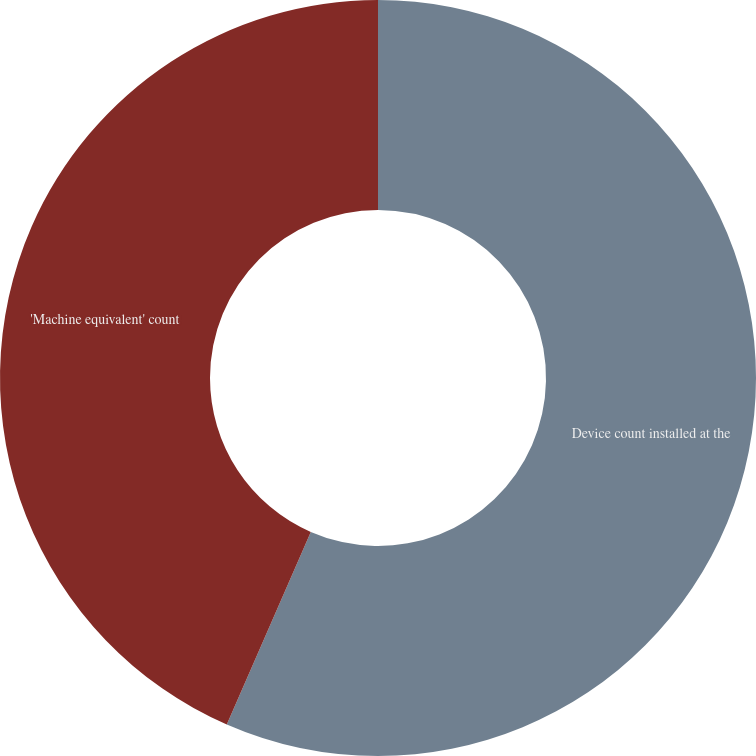Convert chart to OTSL. <chart><loc_0><loc_0><loc_500><loc_500><pie_chart><fcel>Device count installed at the<fcel>'Machine equivalent' count<nl><fcel>56.55%<fcel>43.45%<nl></chart> 